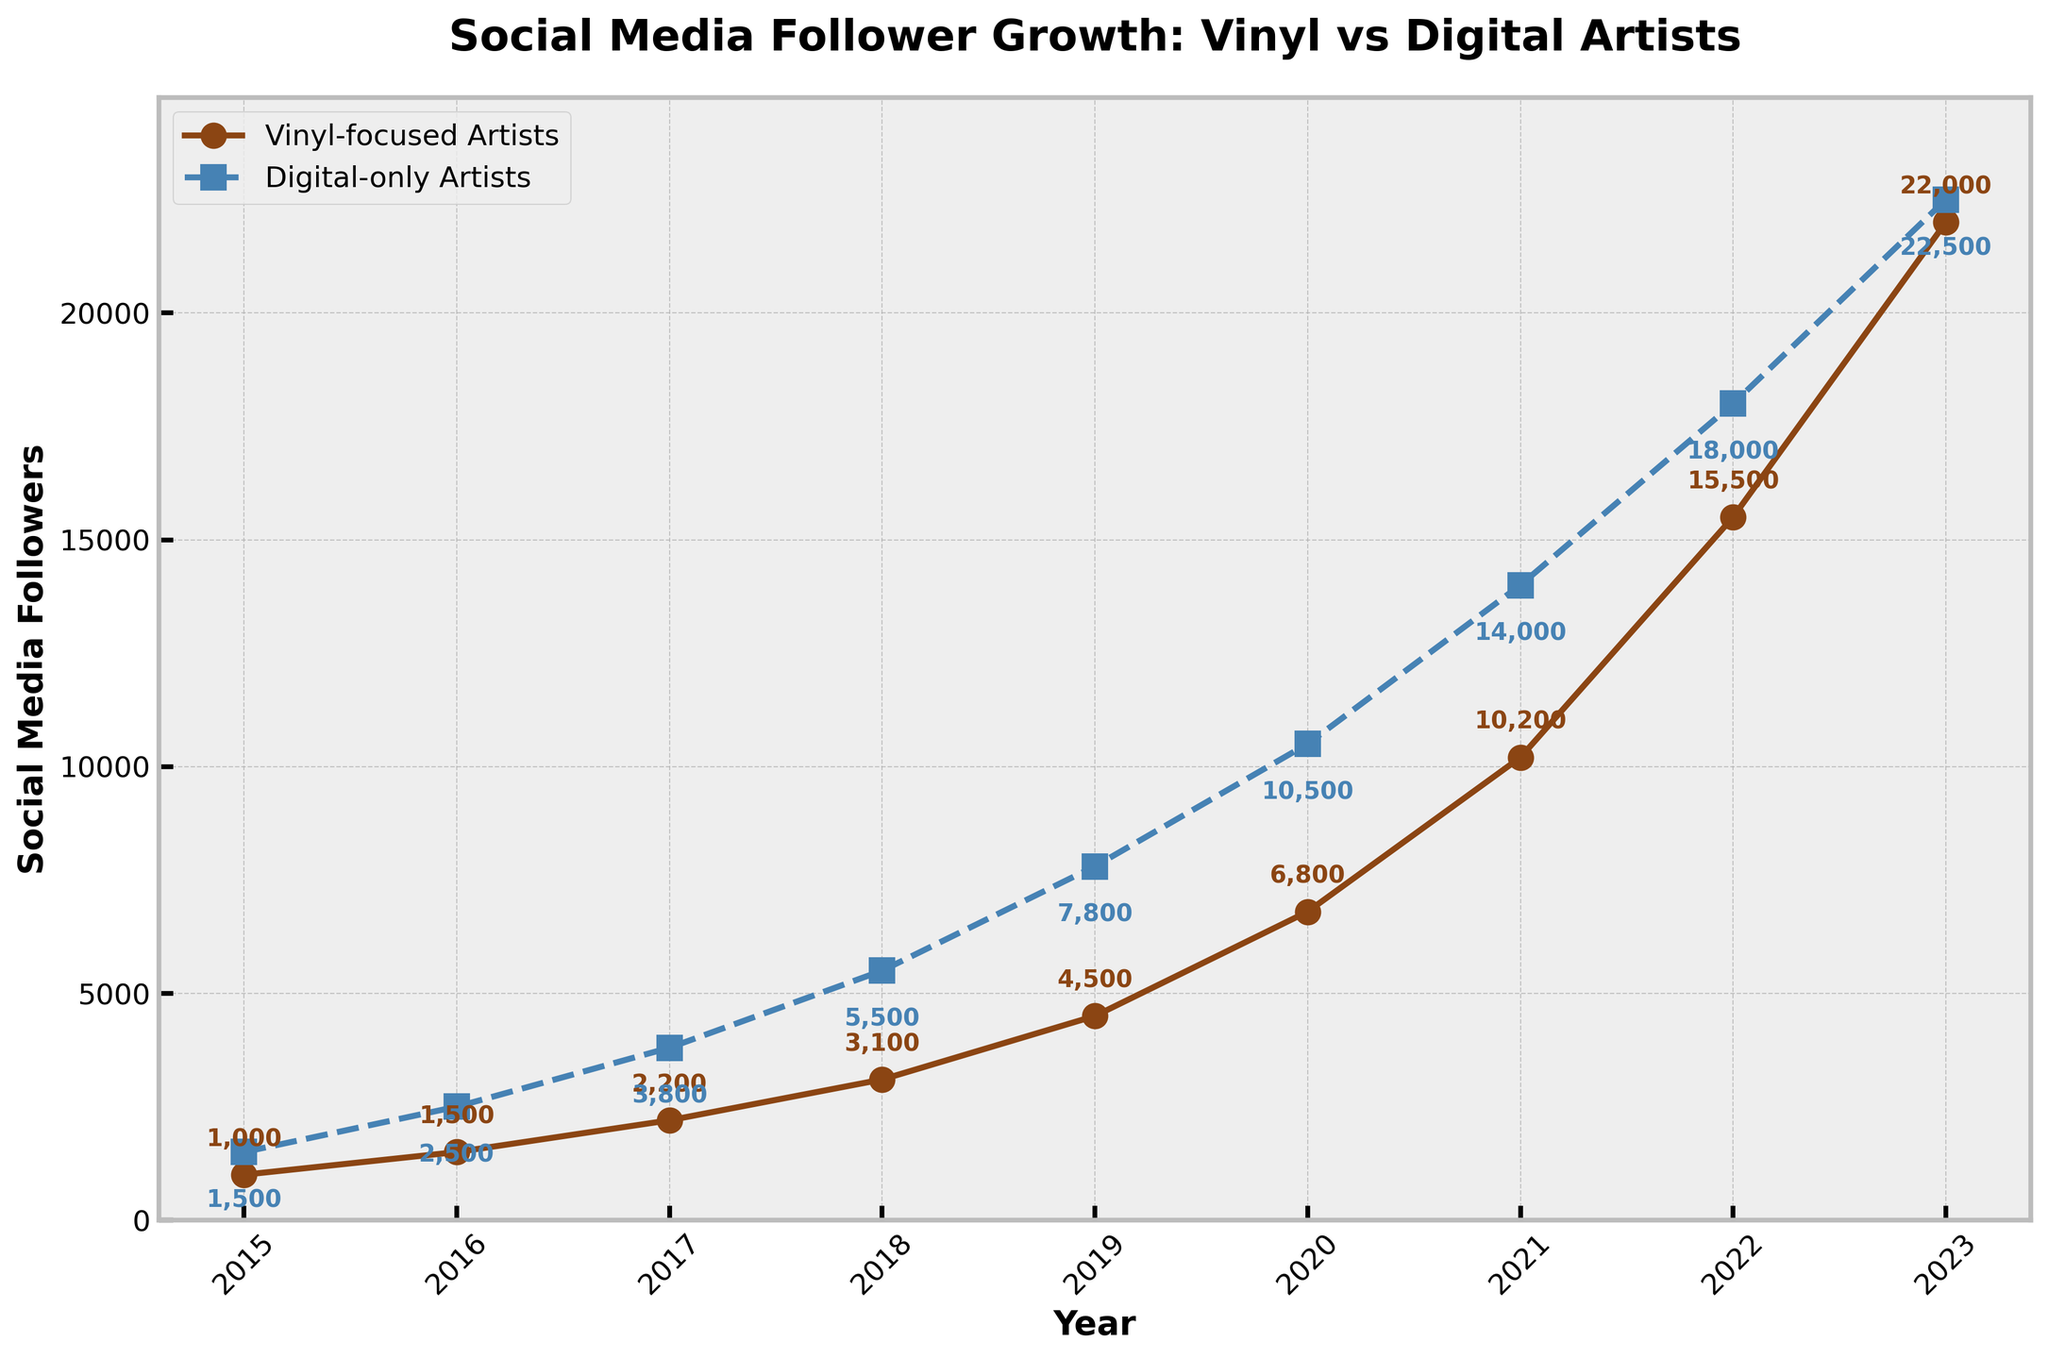What's the difference in social media followers between vinyl-focused artists and digital-only artists in 2019? In 2019, vinyl-focused artists had 4500 followers and digital-only artists had 7800 followers. The difference is 7800 - 4500 = 3300.
Answer: 3300 Between which two years did vinyl-focused artists see the largest growth in social media followers? Vinyl-focused artists' follower counts over the years are 1000, 1500, 2200, 3100, 4500, 6800, 10200, 15500, and 22000. The largest growth is between 2022 and 2023, with an increase of 22000 - 15500 = 6500.
Answer: 2022 and 2023 By how much did digital-only artists’ social media followers increase from 2017 to 2018? In 2017, digital-only artists had 3800 followers, and in 2018, they had 5500 followers. The increase is 5500 - 3800 = 1700.
Answer: 1700 In what year did vinyl-focused artists reach over 10,000 social media followers? According to the plot, vinyl-focused artists reached over 10,000 followers in 2021 with 10200 followers.
Answer: 2021 What is the ratio of social media followers between vinyl-focused and digital-only artists in 2023? In 2023, vinyl-focused artists had 22000 followers, and digital-only artists had 22500 followers. The ratio is 22000 / 22500.
Answer: 0.978 Which type of artist had the higher rate of increase in followers between 2015 and 2023? Vinyl-focused artists increased from 1000 in 2015 to 22000 in 2023, while digital-only artists increased from 1500 to 22500 in the same period. The rate for vinyl-focused artists is (22000 - 1000) / 1000 = 21 and for digital-only artists is (22500 - 1500) / 1500 = 14. Vinyl-focused artists had a higher rate.
Answer: Vinyl-focused artists In what year did the follower count for digital-only artists first exceed 10,000? Digital-only artists first exceeded 10,000 followers in the year 2020 with 10500 followers.
Answer: 2020 By how much did the follower gap close between vinyl-focused and digital-only artists from 2021 to 2023? In 2021, digital-only artists had 14000 followers and vinyl-focused had 10200, a gap of 3800. In 2023, digital-only had 22500 and vinyl-focused had 22000, a gap of 500. The gap closed by 3800 - 500 = 3300.
Answer: 3300 Which type of artist achieved the highest follower count overall and in what year? The highest follower count overall was achieved by digital-only artists in 2023 with 22500 followers.
Answer: Digital-only artists in 2023 